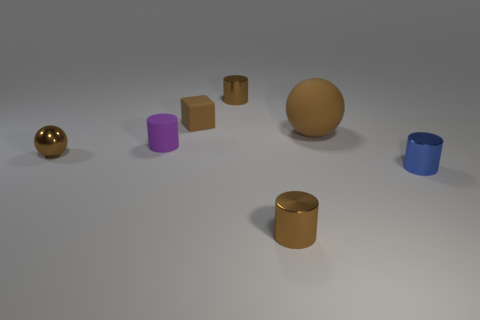Subtract all blue shiny cylinders. How many cylinders are left? 3 Subtract all cyan cubes. How many brown cylinders are left? 2 Add 3 rubber cylinders. How many objects exist? 10 Subtract all blocks. How many objects are left? 6 Subtract all brown cylinders. How many cylinders are left? 2 Subtract 1 spheres. How many spheres are left? 1 Add 6 tiny purple objects. How many tiny purple objects exist? 7 Subtract 1 brown blocks. How many objects are left? 6 Subtract all green cylinders. Subtract all yellow cubes. How many cylinders are left? 4 Subtract all tiny cyan metal objects. Subtract all tiny matte cylinders. How many objects are left? 6 